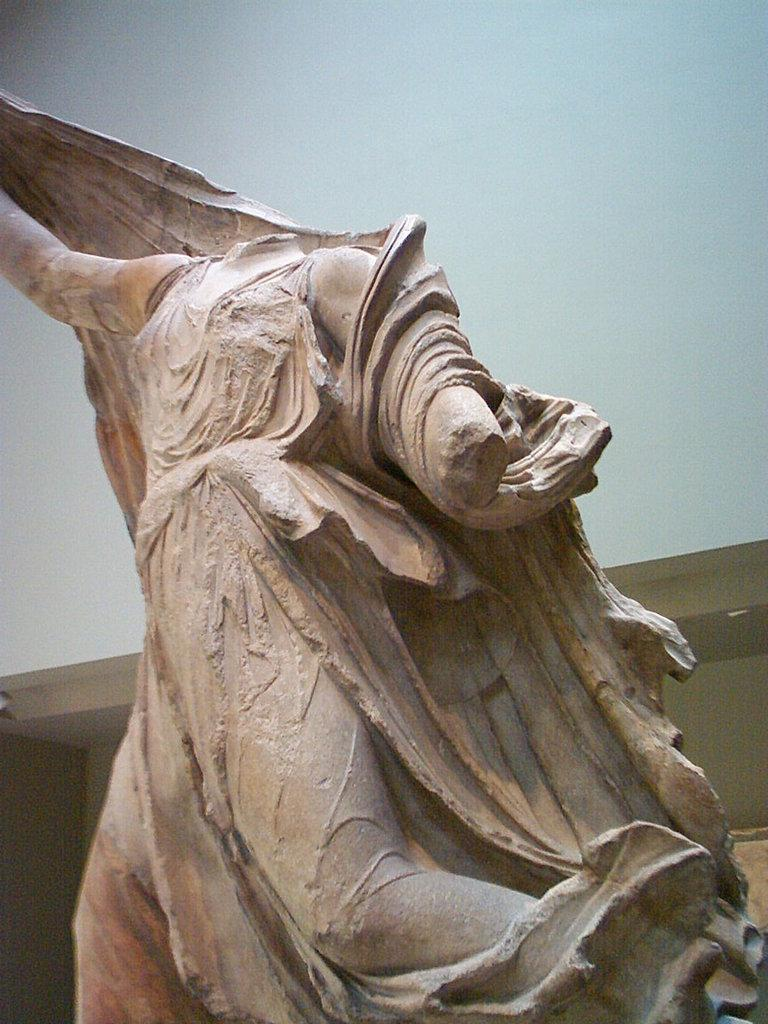What is the main subject of the image? There is a sculpture in the image. What else can be seen in the image besides the sculpture? There is a wall in the image. What is the process of joining the sculpture to the wall in the image? There is no information provided about how the sculpture is joined to the wall, and the image does not show any visible connection between the two. 